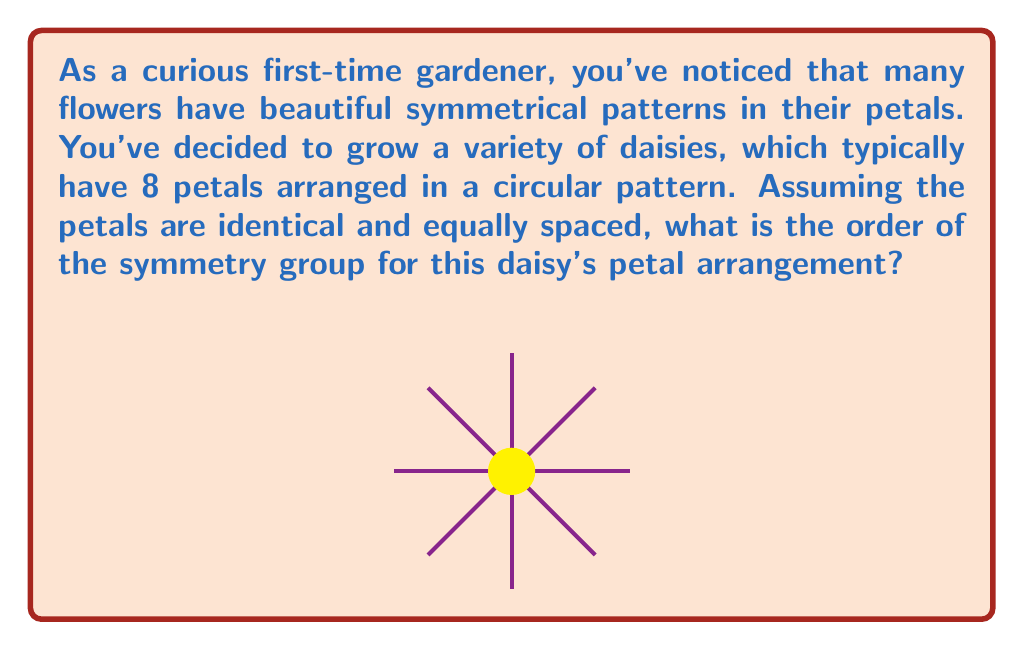Give your solution to this math problem. To find the order of the symmetry group for the daisy's petal arrangement, we need to consider both rotational and reflectional symmetries:

1. Rotational symmetries:
   - The daisy can be rotated by multiples of 45° (360°/8) and maintain its appearance.
   - There are 8 distinct rotations: 0°, 45°, 90°, 135°, 180°, 225°, 270°, 315°.

2. Reflectional symmetries:
   - There are 8 lines of reflection: 4 passing through opposite petals and 4 passing between adjacent petals.

3. Symmetry group:
   - The symmetry group of this arrangement is known as the dihedral group $D_8$.
   - The order of a dihedral group $D_n$ is given by the formula: $|D_n| = 2n$
   - In this case, $n = 8$, so the order of the group is:
     $$|D_8| = 2 \cdot 8 = 16$$

Therefore, the symmetry group of the daisy's petal arrangement has 16 elements, consisting of 8 rotations and 8 reflections.
Answer: 16 